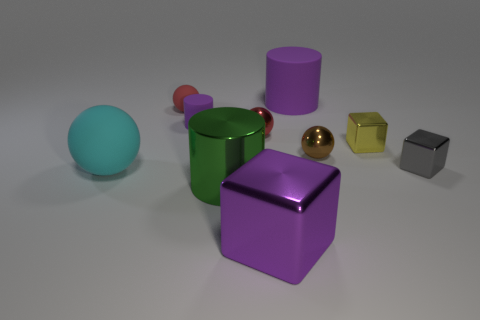There is another cylinder that is the same color as the small rubber cylinder; what is its size?
Make the answer very short. Large. What number of tiny objects are rubber cylinders or gray shiny blocks?
Provide a short and direct response. 2. What number of big brown shiny blocks are there?
Ensure brevity in your answer.  0. Are there an equal number of big cyan matte objects that are right of the large green cylinder and small brown metallic spheres in front of the cyan rubber thing?
Provide a succinct answer. Yes. There is a yellow shiny cube; are there any rubber balls behind it?
Your answer should be very brief. Yes. There is a large metallic object that is behind the large cube; what color is it?
Your answer should be compact. Green. What is the material of the small cube left of the gray thing in front of the big purple cylinder?
Provide a short and direct response. Metal. Are there fewer objects in front of the large ball than red shiny things to the right of the small gray metallic object?
Give a very brief answer. No. How many purple things are big rubber balls or big metallic cubes?
Your response must be concise. 1. Is the number of tiny objects to the left of the large purple block the same as the number of small purple matte cylinders?
Your answer should be very brief. No. 